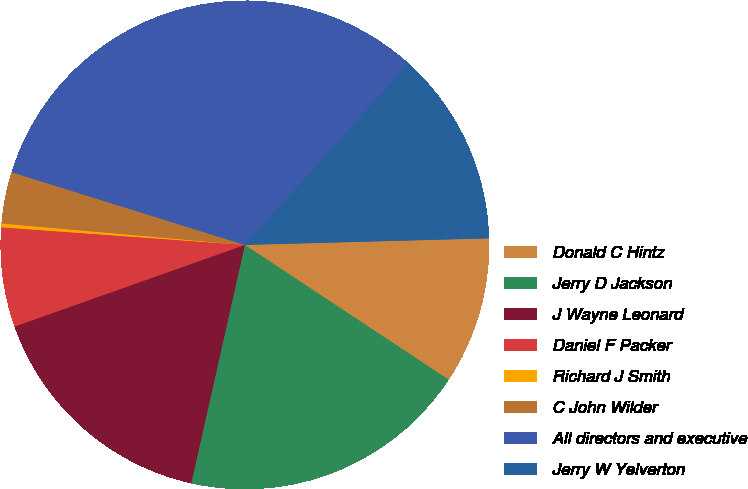Convert chart. <chart><loc_0><loc_0><loc_500><loc_500><pie_chart><fcel>Donald C Hintz<fcel>Jerry D Jackson<fcel>J Wayne Leonard<fcel>Daniel F Packer<fcel>Richard J Smith<fcel>C John Wilder<fcel>All directors and executive<fcel>Jerry W Yelverton<nl><fcel>9.73%<fcel>19.22%<fcel>16.06%<fcel>6.57%<fcel>0.25%<fcel>3.41%<fcel>31.86%<fcel>12.9%<nl></chart> 